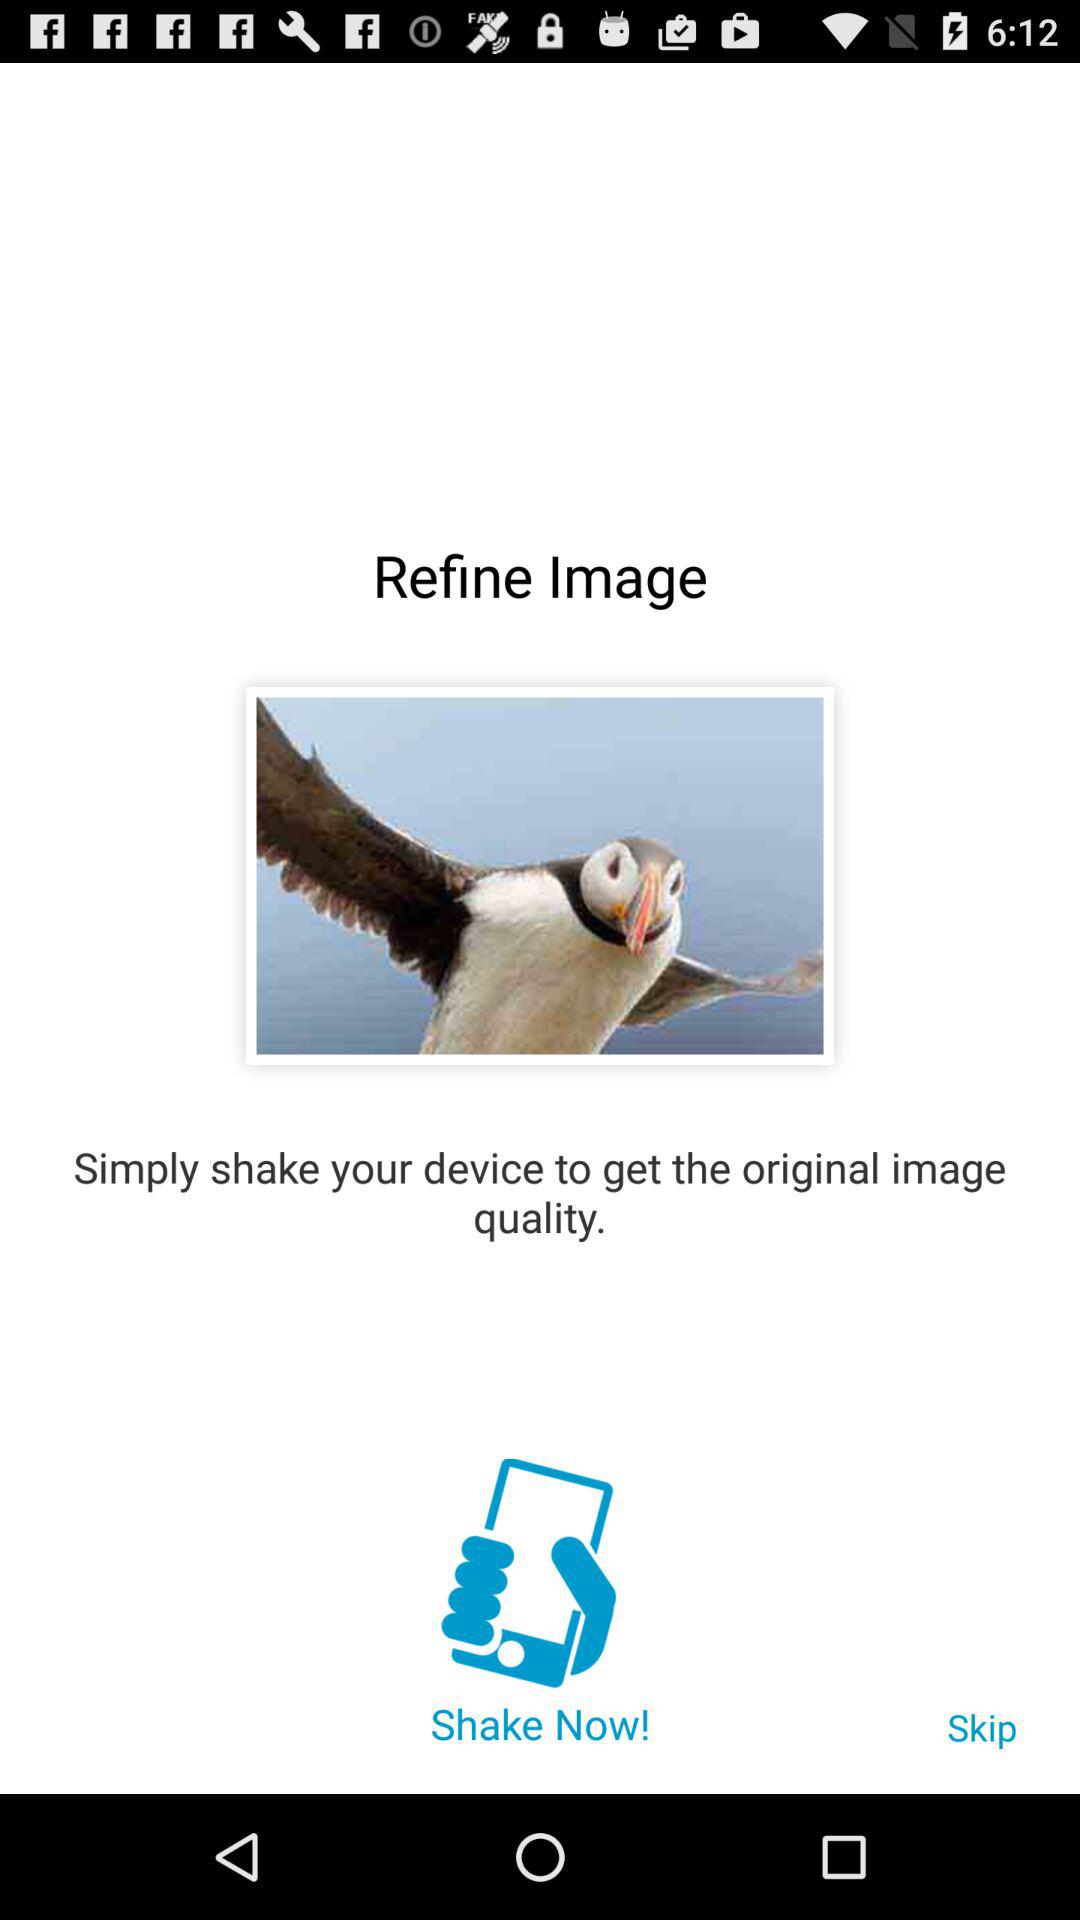What has to be done to get the original image quality? To get the original image quality, shake the device. 